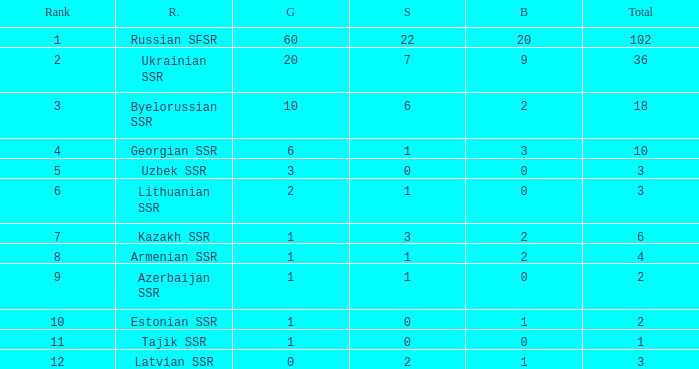What is the sum of bronzes for teams with more than 2 gold, ranked under 3, and less than 22 silver? 9.0. 